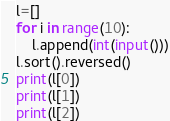<code> <loc_0><loc_0><loc_500><loc_500><_Python_>l=[]
for i in range(10):
	l.append(int(input()))
l.sort().reversed()
print(l[0])
print(l[1])
print(l[2])</code> 